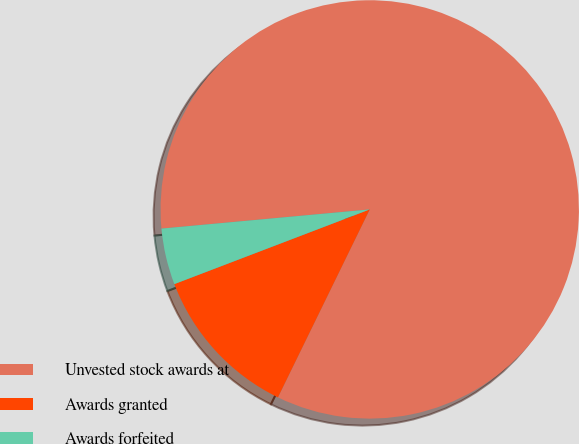<chart> <loc_0><loc_0><loc_500><loc_500><pie_chart><fcel>Unvested stock awards at<fcel>Awards granted<fcel>Awards forfeited<nl><fcel>83.7%<fcel>11.96%<fcel>4.35%<nl></chart> 